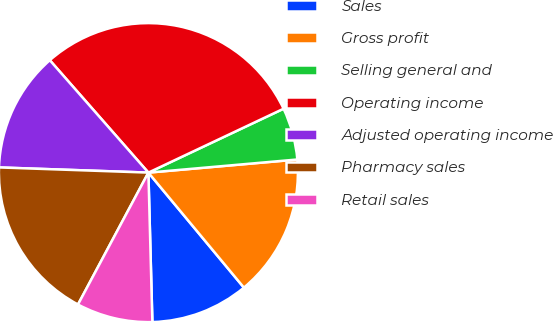Convert chart to OTSL. <chart><loc_0><loc_0><loc_500><loc_500><pie_chart><fcel>Sales<fcel>Gross profit<fcel>Selling general and<fcel>Operating income<fcel>Adjusted operating income<fcel>Pharmacy sales<fcel>Retail sales<nl><fcel>10.61%<fcel>15.37%<fcel>5.63%<fcel>29.44%<fcel>12.99%<fcel>17.75%<fcel>8.23%<nl></chart> 